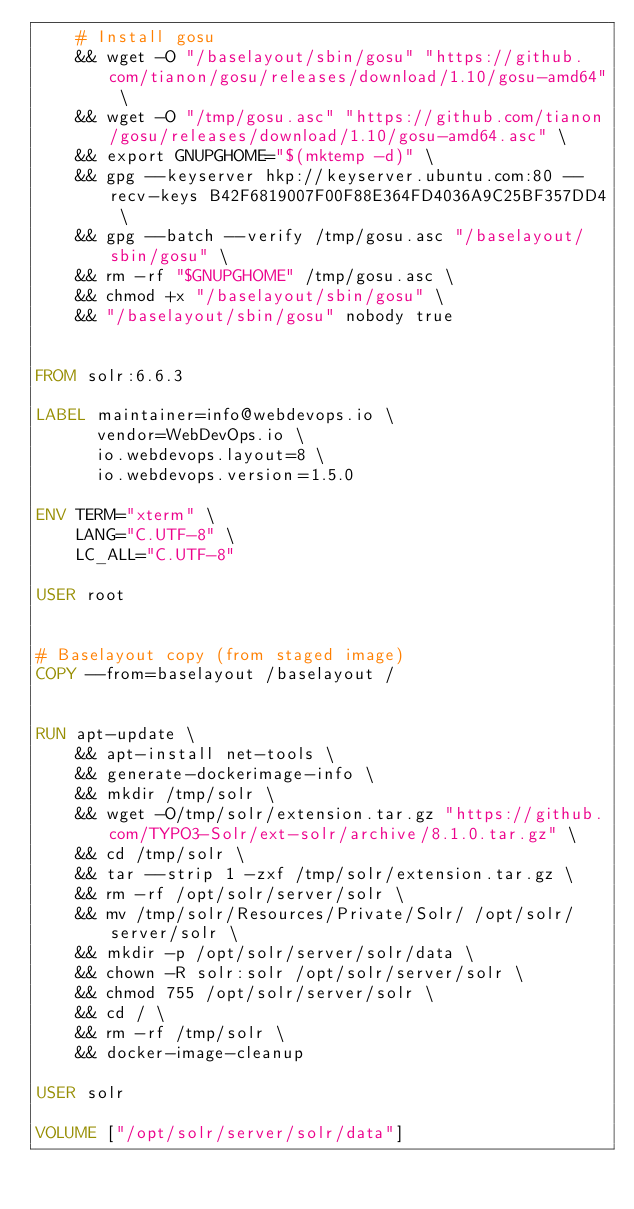Convert code to text. <code><loc_0><loc_0><loc_500><loc_500><_Dockerfile_>    # Install gosu
    && wget -O "/baselayout/sbin/gosu" "https://github.com/tianon/gosu/releases/download/1.10/gosu-amd64" \
    && wget -O "/tmp/gosu.asc" "https://github.com/tianon/gosu/releases/download/1.10/gosu-amd64.asc" \
    && export GNUPGHOME="$(mktemp -d)" \
    && gpg --keyserver hkp://keyserver.ubuntu.com:80 --recv-keys B42F6819007F00F88E364FD4036A9C25BF357DD4 \
    && gpg --batch --verify /tmp/gosu.asc "/baselayout/sbin/gosu" \
    && rm -rf "$GNUPGHOME" /tmp/gosu.asc \
    && chmod +x "/baselayout/sbin/gosu" \
    && "/baselayout/sbin/gosu" nobody true


FROM solr:6.6.3

LABEL maintainer=info@webdevops.io \
      vendor=WebDevOps.io \
      io.webdevops.layout=8 \
      io.webdevops.version=1.5.0

ENV TERM="xterm" \
    LANG="C.UTF-8" \
    LC_ALL="C.UTF-8"

USER root


# Baselayout copy (from staged image)
COPY --from=baselayout /baselayout /


RUN apt-update \
    && apt-install net-tools \
    && generate-dockerimage-info \
    && mkdir /tmp/solr \
    && wget -O/tmp/solr/extension.tar.gz "https://github.com/TYPO3-Solr/ext-solr/archive/8.1.0.tar.gz" \
    && cd /tmp/solr \
    && tar --strip 1 -zxf /tmp/solr/extension.tar.gz \
    && rm -rf /opt/solr/server/solr \
    && mv /tmp/solr/Resources/Private/Solr/ /opt/solr/server/solr \
    && mkdir -p /opt/solr/server/solr/data \
    && chown -R solr:solr /opt/solr/server/solr \
    && chmod 755 /opt/solr/server/solr \
    && cd / \
    && rm -rf /tmp/solr \
    && docker-image-cleanup

USER solr

VOLUME ["/opt/solr/server/solr/data"]
</code> 